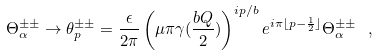<formula> <loc_0><loc_0><loc_500><loc_500>\Theta _ { \alpha } ^ { \pm \pm } \to \theta _ { p } ^ { \pm \pm } = \frac { \epsilon } { 2 \pi } \left ( \mu \pi \gamma ( \frac { b Q } { 2 } ) \right ) ^ { i p / b } e ^ { i \pi \lfloor p - \frac { 1 } { 2 } \rfloor } \Theta _ { \alpha } ^ { \pm \pm } \ ,</formula> 